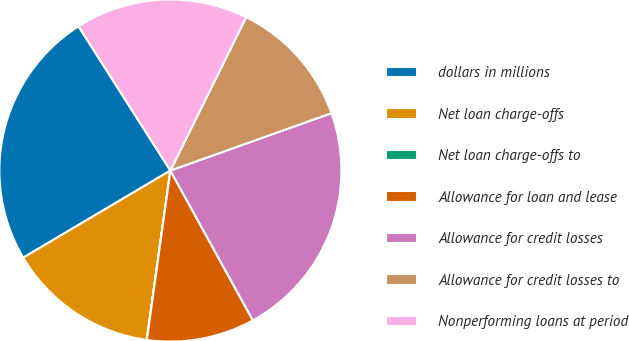Convert chart to OTSL. <chart><loc_0><loc_0><loc_500><loc_500><pie_chart><fcel>dollars in millions<fcel>Net loan charge-offs<fcel>Net loan charge-offs to<fcel>Allowance for loan and lease<fcel>Allowance for credit losses<fcel>Allowance for credit losses to<fcel>Nonperforming loans at period<nl><fcel>24.48%<fcel>14.29%<fcel>0.01%<fcel>10.21%<fcel>22.44%<fcel>12.25%<fcel>16.33%<nl></chart> 